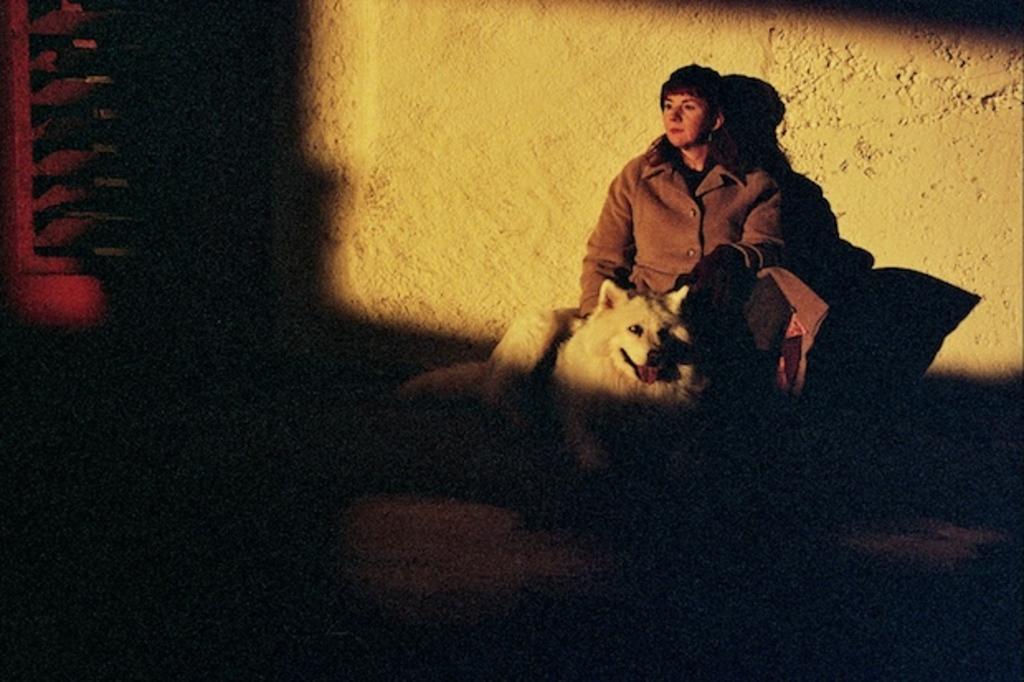How would you summarize this image in a sentence or two? In this image I can see a woman with a white color of dog. I can also see woman is wearing a jacket of brown color. 